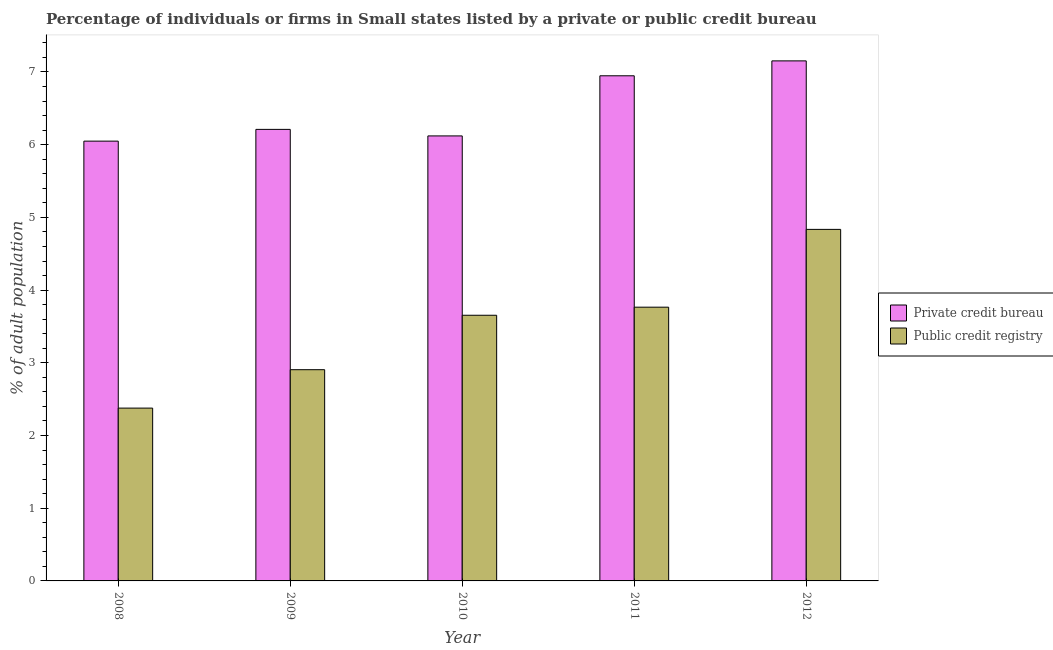How many bars are there on the 5th tick from the right?
Provide a short and direct response. 2. What is the label of the 3rd group of bars from the left?
Your answer should be very brief. 2010. What is the percentage of firms listed by private credit bureau in 2011?
Make the answer very short. 6.95. Across all years, what is the maximum percentage of firms listed by private credit bureau?
Keep it short and to the point. 7.15. Across all years, what is the minimum percentage of firms listed by private credit bureau?
Your response must be concise. 6.05. What is the total percentage of firms listed by private credit bureau in the graph?
Provide a short and direct response. 32.48. What is the difference between the percentage of firms listed by public credit bureau in 2011 and that in 2012?
Provide a succinct answer. -1.07. What is the difference between the percentage of firms listed by public credit bureau in 2008 and the percentage of firms listed by private credit bureau in 2012?
Your answer should be very brief. -2.46. What is the average percentage of firms listed by public credit bureau per year?
Provide a succinct answer. 3.51. In how many years, is the percentage of firms listed by private credit bureau greater than 5.4 %?
Your response must be concise. 5. What is the ratio of the percentage of firms listed by public credit bureau in 2009 to that in 2010?
Your answer should be very brief. 0.8. Is the difference between the percentage of firms listed by public credit bureau in 2008 and 2012 greater than the difference between the percentage of firms listed by private credit bureau in 2008 and 2012?
Your answer should be very brief. No. What is the difference between the highest and the second highest percentage of firms listed by public credit bureau?
Your answer should be very brief. 1.07. What is the difference between the highest and the lowest percentage of firms listed by public credit bureau?
Your answer should be very brief. 2.46. In how many years, is the percentage of firms listed by private credit bureau greater than the average percentage of firms listed by private credit bureau taken over all years?
Ensure brevity in your answer.  2. What does the 1st bar from the left in 2008 represents?
Your answer should be very brief. Private credit bureau. What does the 1st bar from the right in 2010 represents?
Make the answer very short. Public credit registry. Are all the bars in the graph horizontal?
Keep it short and to the point. No. How many years are there in the graph?
Provide a succinct answer. 5. What is the difference between two consecutive major ticks on the Y-axis?
Make the answer very short. 1. Does the graph contain any zero values?
Your response must be concise. No. How are the legend labels stacked?
Offer a terse response. Vertical. What is the title of the graph?
Make the answer very short. Percentage of individuals or firms in Small states listed by a private or public credit bureau. What is the label or title of the Y-axis?
Offer a terse response. % of adult population. What is the % of adult population of Private credit bureau in 2008?
Your response must be concise. 6.05. What is the % of adult population of Public credit registry in 2008?
Offer a terse response. 2.38. What is the % of adult population in Private credit bureau in 2009?
Provide a short and direct response. 6.21. What is the % of adult population in Public credit registry in 2009?
Keep it short and to the point. 2.91. What is the % of adult population in Private credit bureau in 2010?
Offer a terse response. 6.12. What is the % of adult population in Public credit registry in 2010?
Ensure brevity in your answer.  3.65. What is the % of adult population in Private credit bureau in 2011?
Your answer should be very brief. 6.95. What is the % of adult population of Public credit registry in 2011?
Offer a very short reply. 3.77. What is the % of adult population of Private credit bureau in 2012?
Provide a short and direct response. 7.15. What is the % of adult population in Public credit registry in 2012?
Ensure brevity in your answer.  4.83. Across all years, what is the maximum % of adult population of Private credit bureau?
Provide a succinct answer. 7.15. Across all years, what is the maximum % of adult population of Public credit registry?
Ensure brevity in your answer.  4.83. Across all years, what is the minimum % of adult population in Private credit bureau?
Ensure brevity in your answer.  6.05. Across all years, what is the minimum % of adult population of Public credit registry?
Keep it short and to the point. 2.38. What is the total % of adult population of Private credit bureau in the graph?
Provide a short and direct response. 32.48. What is the total % of adult population in Public credit registry in the graph?
Offer a very short reply. 17.54. What is the difference between the % of adult population in Private credit bureau in 2008 and that in 2009?
Offer a very short reply. -0.16. What is the difference between the % of adult population of Public credit registry in 2008 and that in 2009?
Provide a succinct answer. -0.53. What is the difference between the % of adult population of Private credit bureau in 2008 and that in 2010?
Ensure brevity in your answer.  -0.07. What is the difference between the % of adult population of Public credit registry in 2008 and that in 2010?
Offer a terse response. -1.28. What is the difference between the % of adult population of Private credit bureau in 2008 and that in 2011?
Give a very brief answer. -0.9. What is the difference between the % of adult population in Public credit registry in 2008 and that in 2011?
Your answer should be compact. -1.39. What is the difference between the % of adult population of Private credit bureau in 2008 and that in 2012?
Give a very brief answer. -1.1. What is the difference between the % of adult population in Public credit registry in 2008 and that in 2012?
Keep it short and to the point. -2.46. What is the difference between the % of adult population in Private credit bureau in 2009 and that in 2010?
Offer a terse response. 0.09. What is the difference between the % of adult population in Public credit registry in 2009 and that in 2010?
Provide a short and direct response. -0.75. What is the difference between the % of adult population of Private credit bureau in 2009 and that in 2011?
Give a very brief answer. -0.74. What is the difference between the % of adult population in Public credit registry in 2009 and that in 2011?
Ensure brevity in your answer.  -0.86. What is the difference between the % of adult population of Private credit bureau in 2009 and that in 2012?
Offer a terse response. -0.94. What is the difference between the % of adult population in Public credit registry in 2009 and that in 2012?
Ensure brevity in your answer.  -1.93. What is the difference between the % of adult population of Private credit bureau in 2010 and that in 2011?
Give a very brief answer. -0.83. What is the difference between the % of adult population in Public credit registry in 2010 and that in 2011?
Ensure brevity in your answer.  -0.11. What is the difference between the % of adult population of Private credit bureau in 2010 and that in 2012?
Offer a terse response. -1.03. What is the difference between the % of adult population in Public credit registry in 2010 and that in 2012?
Provide a succinct answer. -1.18. What is the difference between the % of adult population of Private credit bureau in 2011 and that in 2012?
Give a very brief answer. -0.2. What is the difference between the % of adult population in Public credit registry in 2011 and that in 2012?
Offer a very short reply. -1.07. What is the difference between the % of adult population in Private credit bureau in 2008 and the % of adult population in Public credit registry in 2009?
Make the answer very short. 3.14. What is the difference between the % of adult population of Private credit bureau in 2008 and the % of adult population of Public credit registry in 2010?
Provide a succinct answer. 2.39. What is the difference between the % of adult population in Private credit bureau in 2008 and the % of adult population in Public credit registry in 2011?
Offer a very short reply. 2.28. What is the difference between the % of adult population of Private credit bureau in 2008 and the % of adult population of Public credit registry in 2012?
Your response must be concise. 1.21. What is the difference between the % of adult population of Private credit bureau in 2009 and the % of adult population of Public credit registry in 2010?
Give a very brief answer. 2.56. What is the difference between the % of adult population in Private credit bureau in 2009 and the % of adult population in Public credit registry in 2011?
Your answer should be compact. 2.45. What is the difference between the % of adult population of Private credit bureau in 2009 and the % of adult population of Public credit registry in 2012?
Your response must be concise. 1.38. What is the difference between the % of adult population in Private credit bureau in 2010 and the % of adult population in Public credit registry in 2011?
Provide a succinct answer. 2.36. What is the difference between the % of adult population in Private credit bureau in 2010 and the % of adult population in Public credit registry in 2012?
Give a very brief answer. 1.29. What is the difference between the % of adult population of Private credit bureau in 2011 and the % of adult population of Public credit registry in 2012?
Keep it short and to the point. 2.11. What is the average % of adult population in Private credit bureau per year?
Provide a short and direct response. 6.5. What is the average % of adult population in Public credit registry per year?
Keep it short and to the point. 3.51. In the year 2008, what is the difference between the % of adult population of Private credit bureau and % of adult population of Public credit registry?
Your answer should be very brief. 3.67. In the year 2009, what is the difference between the % of adult population of Private credit bureau and % of adult population of Public credit registry?
Provide a succinct answer. 3.31. In the year 2010, what is the difference between the % of adult population in Private credit bureau and % of adult population in Public credit registry?
Provide a short and direct response. 2.47. In the year 2011, what is the difference between the % of adult population of Private credit bureau and % of adult population of Public credit registry?
Provide a short and direct response. 3.18. In the year 2012, what is the difference between the % of adult population of Private credit bureau and % of adult population of Public credit registry?
Your response must be concise. 2.32. What is the ratio of the % of adult population in Public credit registry in 2008 to that in 2009?
Give a very brief answer. 0.82. What is the ratio of the % of adult population in Private credit bureau in 2008 to that in 2010?
Ensure brevity in your answer.  0.99. What is the ratio of the % of adult population in Public credit registry in 2008 to that in 2010?
Your answer should be very brief. 0.65. What is the ratio of the % of adult population of Private credit bureau in 2008 to that in 2011?
Give a very brief answer. 0.87. What is the ratio of the % of adult population of Public credit registry in 2008 to that in 2011?
Provide a short and direct response. 0.63. What is the ratio of the % of adult population in Private credit bureau in 2008 to that in 2012?
Your answer should be compact. 0.85. What is the ratio of the % of adult population in Public credit registry in 2008 to that in 2012?
Make the answer very short. 0.49. What is the ratio of the % of adult population of Private credit bureau in 2009 to that in 2010?
Provide a short and direct response. 1.01. What is the ratio of the % of adult population in Public credit registry in 2009 to that in 2010?
Keep it short and to the point. 0.8. What is the ratio of the % of adult population of Private credit bureau in 2009 to that in 2011?
Offer a terse response. 0.89. What is the ratio of the % of adult population of Public credit registry in 2009 to that in 2011?
Give a very brief answer. 0.77. What is the ratio of the % of adult population of Private credit bureau in 2009 to that in 2012?
Provide a short and direct response. 0.87. What is the ratio of the % of adult population in Public credit registry in 2009 to that in 2012?
Offer a terse response. 0.6. What is the ratio of the % of adult population in Private credit bureau in 2010 to that in 2011?
Offer a very short reply. 0.88. What is the ratio of the % of adult population in Public credit registry in 2010 to that in 2011?
Ensure brevity in your answer.  0.97. What is the ratio of the % of adult population of Private credit bureau in 2010 to that in 2012?
Provide a succinct answer. 0.86. What is the ratio of the % of adult population in Public credit registry in 2010 to that in 2012?
Give a very brief answer. 0.76. What is the ratio of the % of adult population in Private credit bureau in 2011 to that in 2012?
Keep it short and to the point. 0.97. What is the ratio of the % of adult population in Public credit registry in 2011 to that in 2012?
Your answer should be very brief. 0.78. What is the difference between the highest and the second highest % of adult population of Private credit bureau?
Provide a short and direct response. 0.2. What is the difference between the highest and the second highest % of adult population of Public credit registry?
Your response must be concise. 1.07. What is the difference between the highest and the lowest % of adult population of Private credit bureau?
Your response must be concise. 1.1. What is the difference between the highest and the lowest % of adult population of Public credit registry?
Provide a succinct answer. 2.46. 